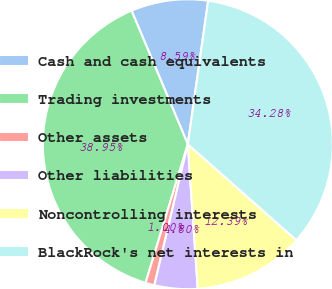Convert chart. <chart><loc_0><loc_0><loc_500><loc_500><pie_chart><fcel>Cash and cash equivalents<fcel>Trading investments<fcel>Other assets<fcel>Other liabilities<fcel>Noncontrolling interests<fcel>BlackRock's net interests in<nl><fcel>8.59%<fcel>38.95%<fcel>1.0%<fcel>4.8%<fcel>12.39%<fcel>34.28%<nl></chart> 